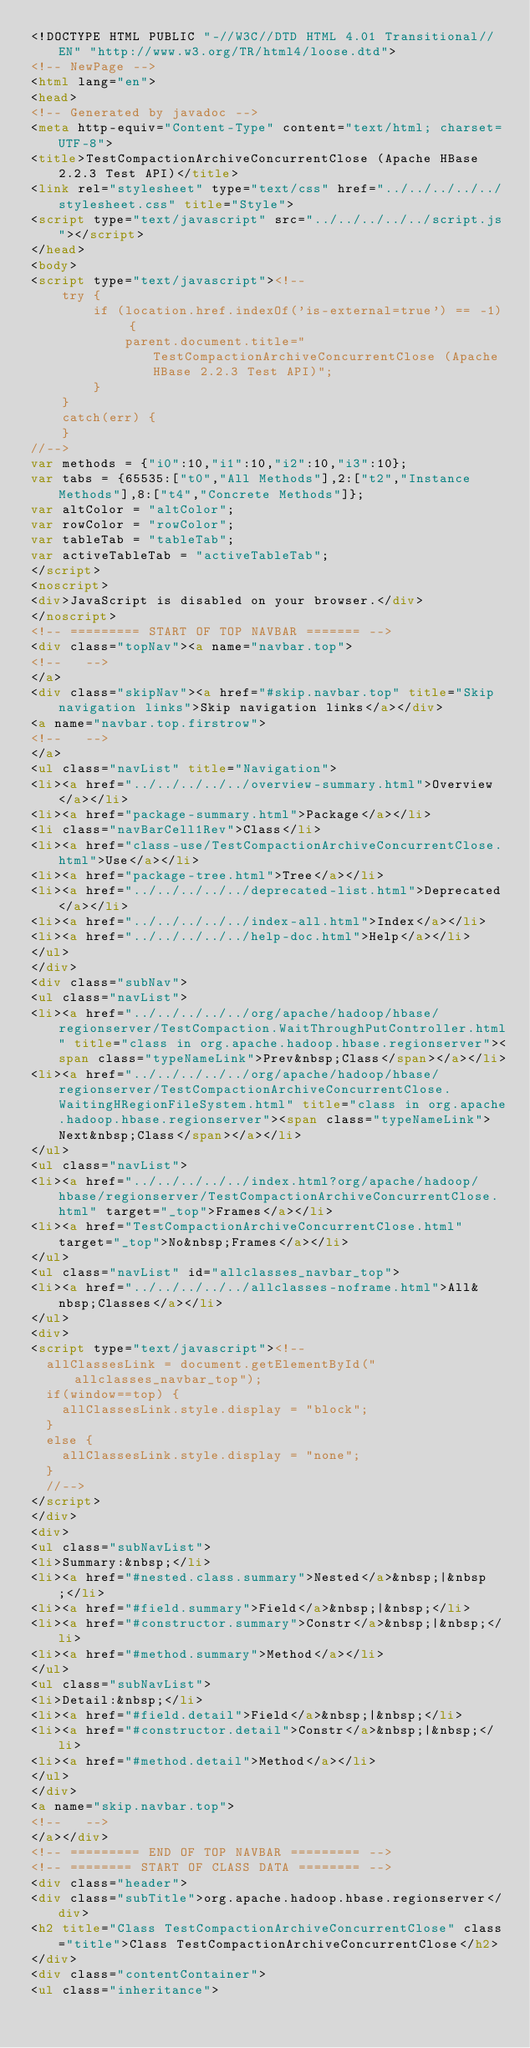Convert code to text. <code><loc_0><loc_0><loc_500><loc_500><_HTML_><!DOCTYPE HTML PUBLIC "-//W3C//DTD HTML 4.01 Transitional//EN" "http://www.w3.org/TR/html4/loose.dtd">
<!-- NewPage -->
<html lang="en">
<head>
<!-- Generated by javadoc -->
<meta http-equiv="Content-Type" content="text/html; charset=UTF-8">
<title>TestCompactionArchiveConcurrentClose (Apache HBase 2.2.3 Test API)</title>
<link rel="stylesheet" type="text/css" href="../../../../../stylesheet.css" title="Style">
<script type="text/javascript" src="../../../../../script.js"></script>
</head>
<body>
<script type="text/javascript"><!--
    try {
        if (location.href.indexOf('is-external=true') == -1) {
            parent.document.title="TestCompactionArchiveConcurrentClose (Apache HBase 2.2.3 Test API)";
        }
    }
    catch(err) {
    }
//-->
var methods = {"i0":10,"i1":10,"i2":10,"i3":10};
var tabs = {65535:["t0","All Methods"],2:["t2","Instance Methods"],8:["t4","Concrete Methods"]};
var altColor = "altColor";
var rowColor = "rowColor";
var tableTab = "tableTab";
var activeTableTab = "activeTableTab";
</script>
<noscript>
<div>JavaScript is disabled on your browser.</div>
</noscript>
<!-- ========= START OF TOP NAVBAR ======= -->
<div class="topNav"><a name="navbar.top">
<!--   -->
</a>
<div class="skipNav"><a href="#skip.navbar.top" title="Skip navigation links">Skip navigation links</a></div>
<a name="navbar.top.firstrow">
<!--   -->
</a>
<ul class="navList" title="Navigation">
<li><a href="../../../../../overview-summary.html">Overview</a></li>
<li><a href="package-summary.html">Package</a></li>
<li class="navBarCell1Rev">Class</li>
<li><a href="class-use/TestCompactionArchiveConcurrentClose.html">Use</a></li>
<li><a href="package-tree.html">Tree</a></li>
<li><a href="../../../../../deprecated-list.html">Deprecated</a></li>
<li><a href="../../../../../index-all.html">Index</a></li>
<li><a href="../../../../../help-doc.html">Help</a></li>
</ul>
</div>
<div class="subNav">
<ul class="navList">
<li><a href="../../../../../org/apache/hadoop/hbase/regionserver/TestCompaction.WaitThroughPutController.html" title="class in org.apache.hadoop.hbase.regionserver"><span class="typeNameLink">Prev&nbsp;Class</span></a></li>
<li><a href="../../../../../org/apache/hadoop/hbase/regionserver/TestCompactionArchiveConcurrentClose.WaitingHRegionFileSystem.html" title="class in org.apache.hadoop.hbase.regionserver"><span class="typeNameLink">Next&nbsp;Class</span></a></li>
</ul>
<ul class="navList">
<li><a href="../../../../../index.html?org/apache/hadoop/hbase/regionserver/TestCompactionArchiveConcurrentClose.html" target="_top">Frames</a></li>
<li><a href="TestCompactionArchiveConcurrentClose.html" target="_top">No&nbsp;Frames</a></li>
</ul>
<ul class="navList" id="allclasses_navbar_top">
<li><a href="../../../../../allclasses-noframe.html">All&nbsp;Classes</a></li>
</ul>
<div>
<script type="text/javascript"><!--
  allClassesLink = document.getElementById("allclasses_navbar_top");
  if(window==top) {
    allClassesLink.style.display = "block";
  }
  else {
    allClassesLink.style.display = "none";
  }
  //-->
</script>
</div>
<div>
<ul class="subNavList">
<li>Summary:&nbsp;</li>
<li><a href="#nested.class.summary">Nested</a>&nbsp;|&nbsp;</li>
<li><a href="#field.summary">Field</a>&nbsp;|&nbsp;</li>
<li><a href="#constructor.summary">Constr</a>&nbsp;|&nbsp;</li>
<li><a href="#method.summary">Method</a></li>
</ul>
<ul class="subNavList">
<li>Detail:&nbsp;</li>
<li><a href="#field.detail">Field</a>&nbsp;|&nbsp;</li>
<li><a href="#constructor.detail">Constr</a>&nbsp;|&nbsp;</li>
<li><a href="#method.detail">Method</a></li>
</ul>
</div>
<a name="skip.navbar.top">
<!--   -->
</a></div>
<!-- ========= END OF TOP NAVBAR ========= -->
<!-- ======== START OF CLASS DATA ======== -->
<div class="header">
<div class="subTitle">org.apache.hadoop.hbase.regionserver</div>
<h2 title="Class TestCompactionArchiveConcurrentClose" class="title">Class TestCompactionArchiveConcurrentClose</h2>
</div>
<div class="contentContainer">
<ul class="inheritance"></code> 